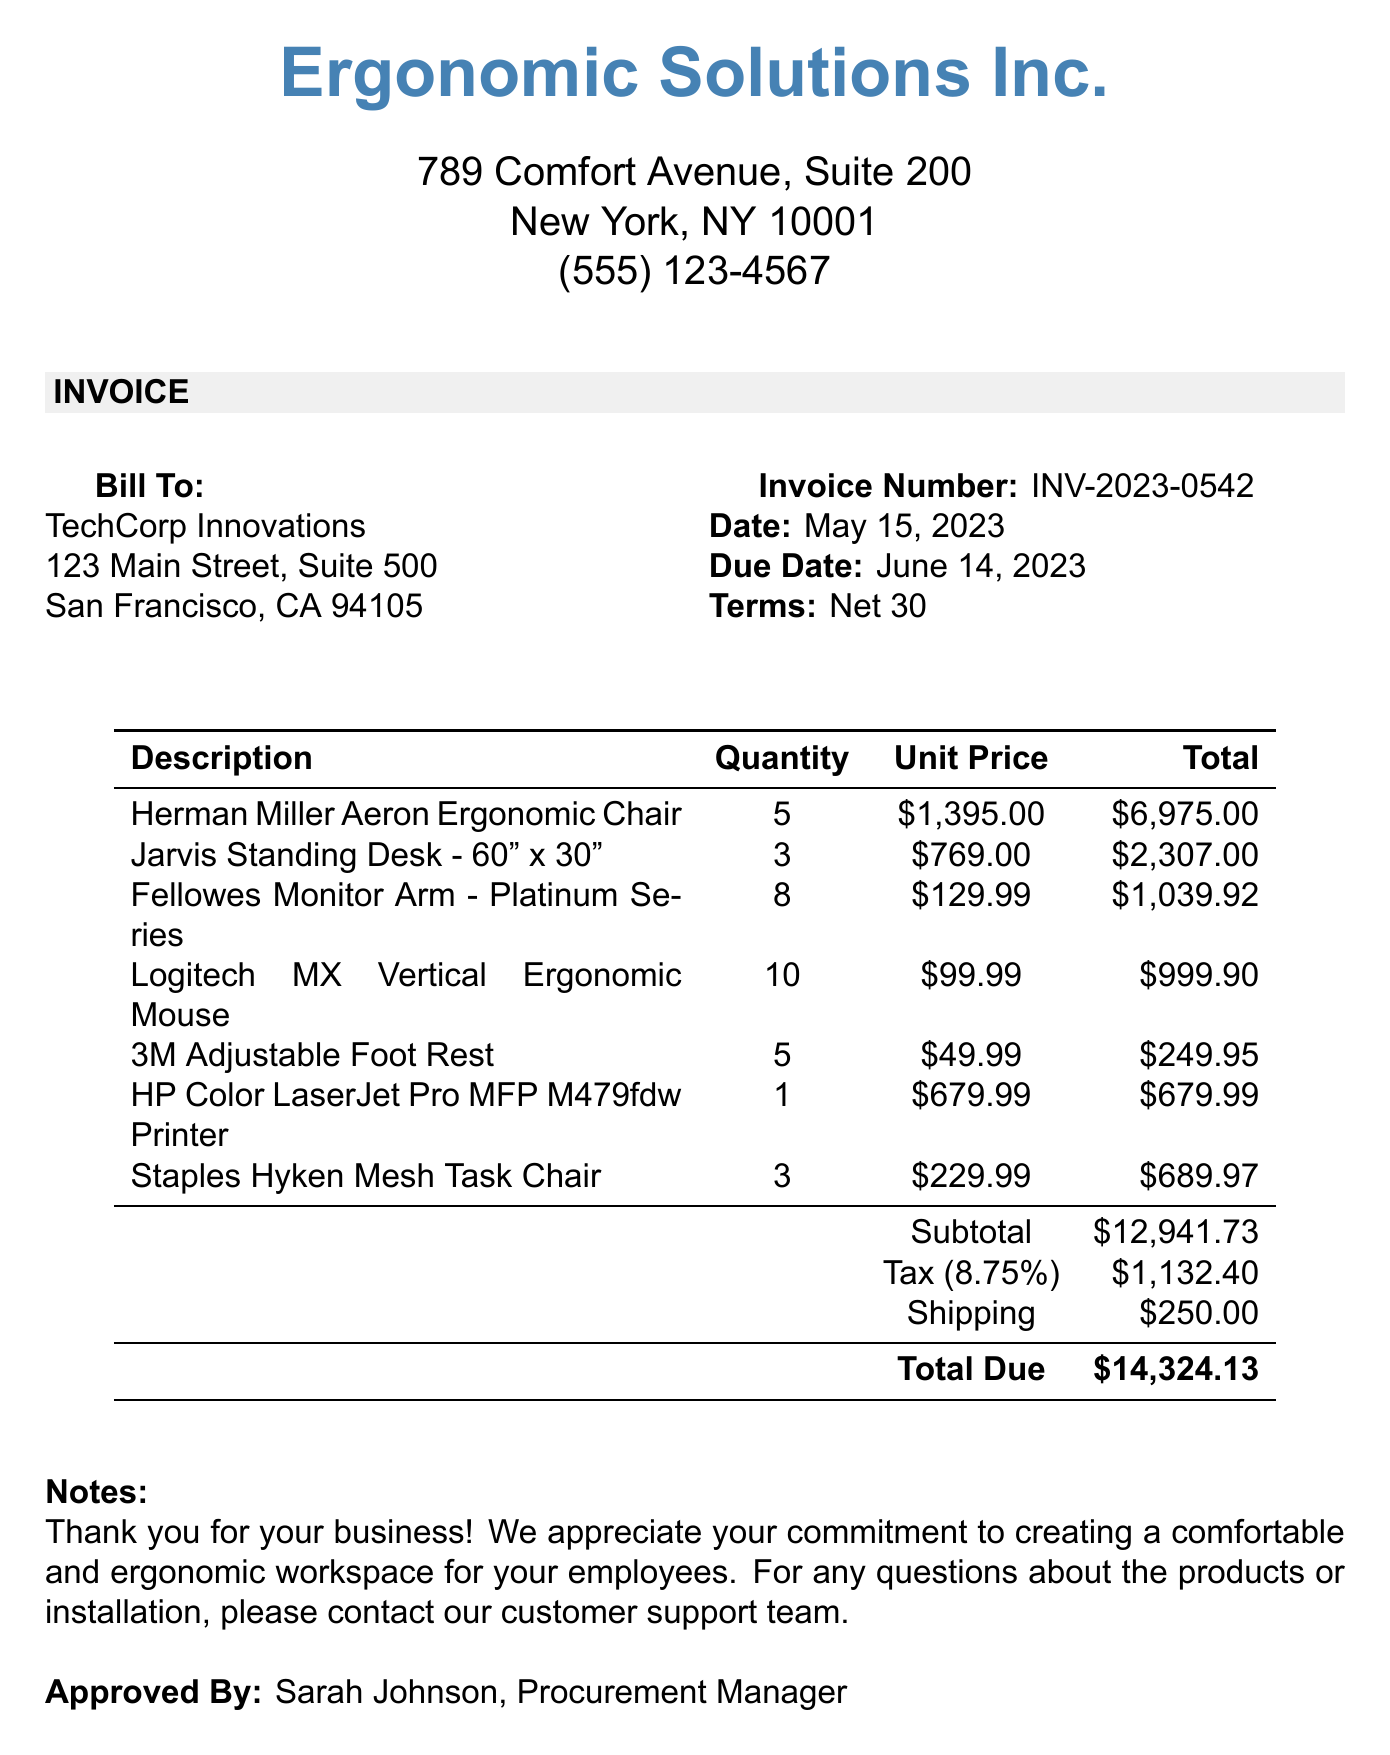what is the invoice number? The invoice number is clearly listed in the document for easy reference.
Answer: INV-2023-0542 who is the bill to organization? The document explicitly states the organization being billed for the items.
Answer: TechCorp Innovations what is the total amount due? The total amount due is the final figure listed at the end of the invoice calculations.
Answer: $14,324.13 how many Herman Miller Aeron chairs were ordered? The quantity of Herman Miller Aeron chairs is shown alongside the description in the item list.
Answer: 5 what is the subtotal before tax and shipping? The subtotal appears as a line item in the invoice before tax and shipping are added.
Answer: $12,941.73 who approved the invoice? The name of the person who approved the invoice is provided in the document.
Answer: Sarah Johnson, Procurement Manager what is the tax rate applied to the invoice? The invoice includes a specific percentage for the tax rate in the calculations section.
Answer: 8.75% how many Logitech MX Vertical Ergonomic Mice were included in the order? The quantity of Logitech MX Vertical Ergonomic Mice is stated next to the product in the itemized list.
Answer: 10 what is the shipping cost? The shipping cost is explicitly listed in the invoice as an additional charge.
Answer: $250.00 